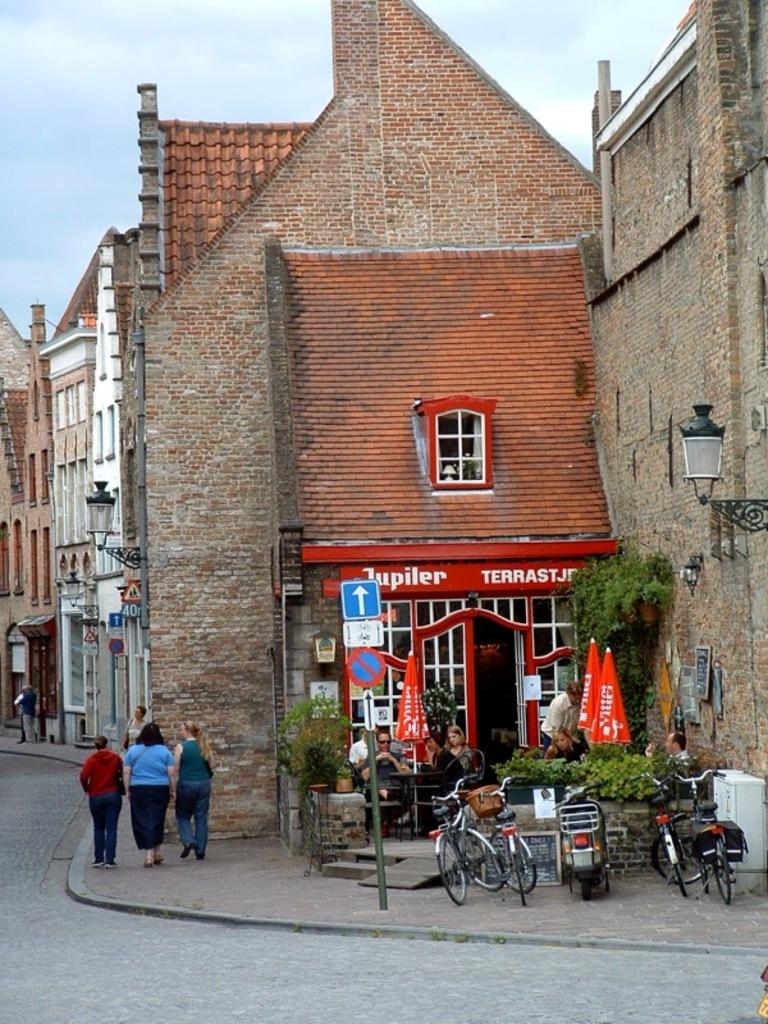<image>
Give a short and clear explanation of the subsequent image. A quaint old building has a red awning advertising Jupiler. 